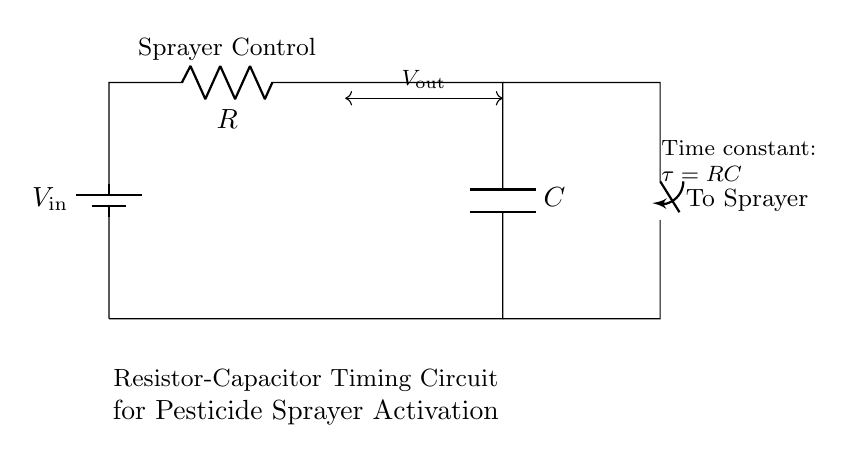What is the input voltage of this circuit? The input voltage is noted as V_in in the circuit diagram. It represents the voltage supplied to the circuit, typically from a battery.
Answer: V_in What components are present in this circuit? The components shown in the circuit diagram include a battery (power source), a resistor labeled as 'Sprayer Control', a capacitor, and a switch leading to the sprayer.
Answer: Battery, resistor, capacitor, switch What is the purpose of the resistor in this circuit? The resistor, labeled as 'Sprayer Control', is used to limit the current flow and is part of the time constant calculation for the timing circuit.
Answer: Current limiting What is the time constant of this circuit? The time constant τ is defined by the formula τ = RC, where R is the resistance and C is the capacitance. This time constant represents the time it takes for the capacitor to charge to about 63.2% of the input voltage.
Answer: τ = RC How does the switch function in this circuit diagram? The switch connects the capacitor to the sprayer when closed, allowing the stored charge to activate the sprayer. When open, it disrupts the current flow.
Answer: Controls sprayer activation What happens when the capacitor is fully charged? When the capacitor is fully charged, it reaches the input voltage level and stops drawing current. At this point, the voltage across the capacitor equals V_in, and the sprayer remains activated until the switch is opened.
Answer: Stops current flow What role does the capacitor play in timing the sprayer? The capacitor stores electrical charge and, together with the resistor, determines the timing of the sprayer's activation by controlling how quickly the circuit reaches the threshold voltage needed to trigger the sprayer.
Answer: Timing control 